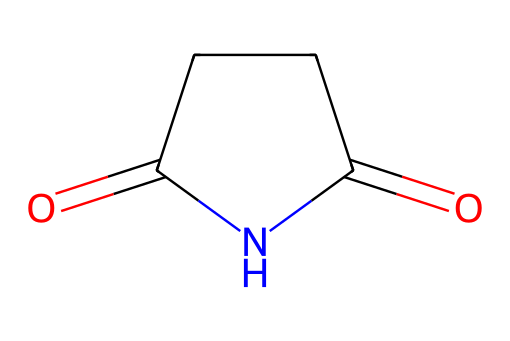What is the molecular formula of succinimide? By analyzing the SMILES representation, we count the individual atoms present: there are 4 carbons (C), 5 hydrogens (H), 2 oxygens (O), and 1 nitrogen (N). Thus, the molecular formula is C4H5NO2.
Answer: C4H5NO2 How many rings are present in the chemical structure? The structure shows a cyclic arrangement of atoms. Since there's a closed loop formed by the carbon atoms and the nitrogen within the carbon framework, there is one ring in succinimide.
Answer: 1 What type of functional groups are present in succinimide? The chemical structure indicates the presence of carbonyls (C=O) and an amide group (C=O, N). These characteristics classify succinimide as containing both ketones and amides.
Answer: carbonyl, amide Does succinimide contain a saturated or unsaturated ring? In the structure, the ring contains a nitrogen atom and is connected through single carbon-carbon bonds along with one carbonyl double bond. Thus, it is classified as a saturated ring because there are no double bonds between the ring carbons.
Answer: saturated What is the primary reason succinimide is used as a food preservative? Succinimide possesses strong antimicrobial properties due to its ability to inhibit microbial growth, which makes it effective as a food preservative.
Answer: antimicrobial properties How many total atoms are in the chemical structure? Counting all the atoms, we have 4 carbon, 5 hydrogen, 2 oxygen, and 1 nitrogen. Adding these together gives us a total of 12 atoms.
Answer: 12 